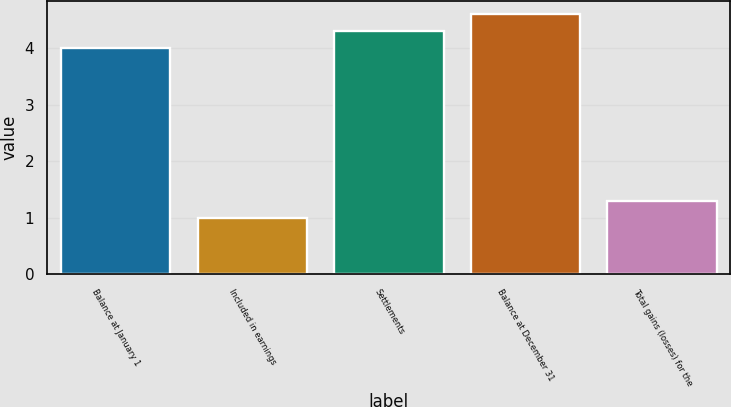Convert chart. <chart><loc_0><loc_0><loc_500><loc_500><bar_chart><fcel>Balance at January 1<fcel>Included in earnings<fcel>Settlements<fcel>Balance at December 31<fcel>Total gains (losses) for the<nl><fcel>4<fcel>1<fcel>4.3<fcel>4.6<fcel>1.3<nl></chart> 